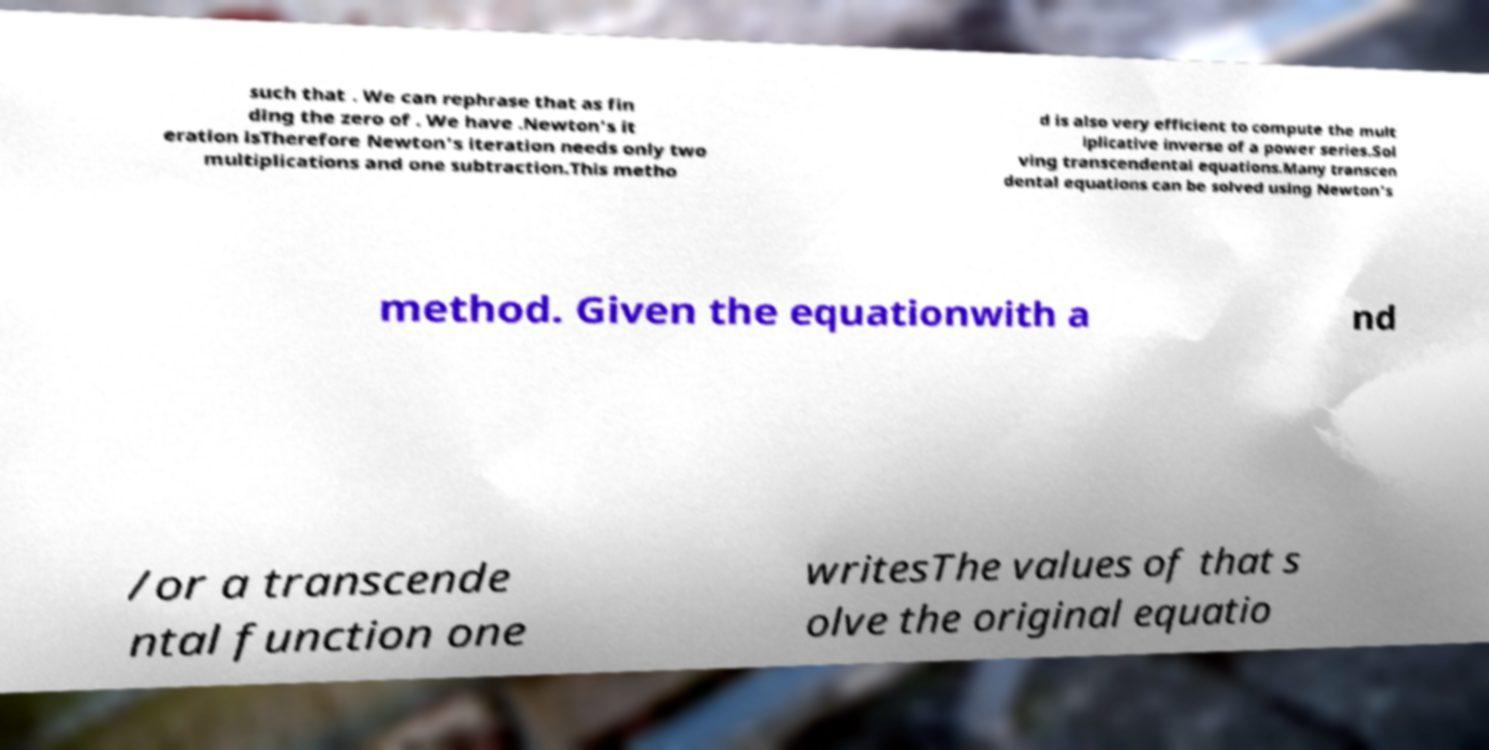I need the written content from this picture converted into text. Can you do that? such that . We can rephrase that as fin ding the zero of . We have .Newton's it eration isTherefore Newton's iteration needs only two multiplications and one subtraction.This metho d is also very efficient to compute the mult iplicative inverse of a power series.Sol ving transcendental equations.Many transcen dental equations can be solved using Newton's method. Given the equationwith a nd /or a transcende ntal function one writesThe values of that s olve the original equatio 